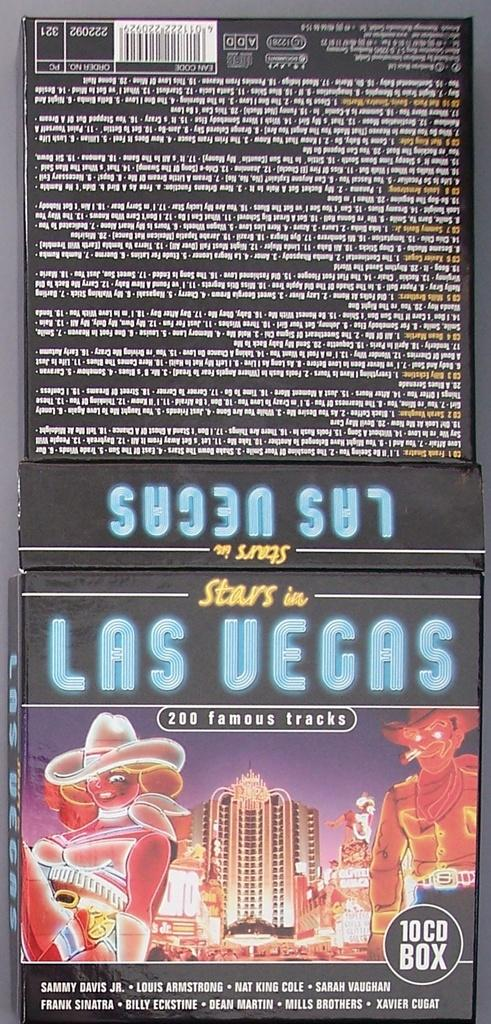<image>
Present a compact description of the photo's key features. Label that says Stars in Las Vegas showing a woman and a cowboy. 